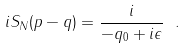Convert formula to latex. <formula><loc_0><loc_0><loc_500><loc_500>i S _ { N } ( p - q ) = \frac { i } { - q _ { 0 } + i \epsilon } \ .</formula> 